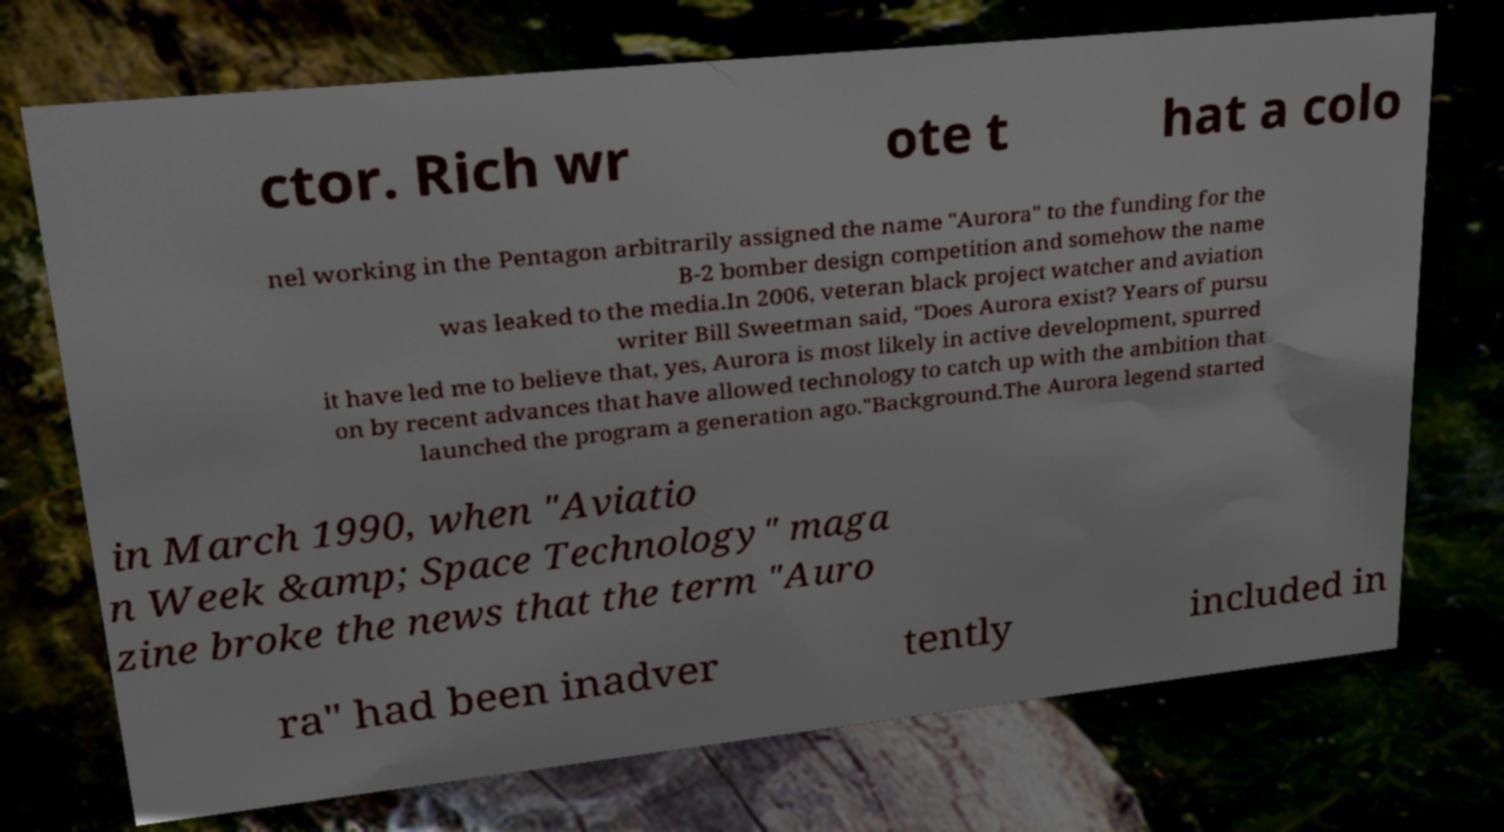What messages or text are displayed in this image? I need them in a readable, typed format. ctor. Rich wr ote t hat a colo nel working in the Pentagon arbitrarily assigned the name "Aurora" to the funding for the B-2 bomber design competition and somehow the name was leaked to the media.In 2006, veteran black project watcher and aviation writer Bill Sweetman said, "Does Aurora exist? Years of pursu it have led me to believe that, yes, Aurora is most likely in active development, spurred on by recent advances that have allowed technology to catch up with the ambition that launched the program a generation ago."Background.The Aurora legend started in March 1990, when "Aviatio n Week &amp; Space Technology" maga zine broke the news that the term "Auro ra" had been inadver tently included in 